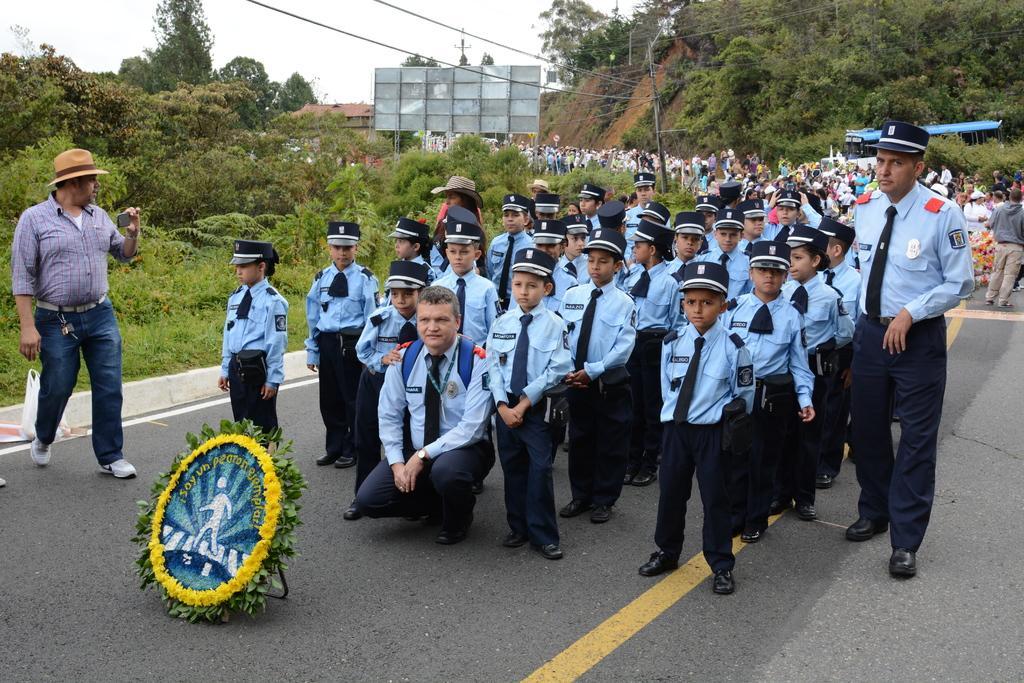Describe this image in one or two sentences. In this picture we can see a group of people standing on the road, shield, trees, plastic cover, hoarding, wires and in the background we can see the sky. 